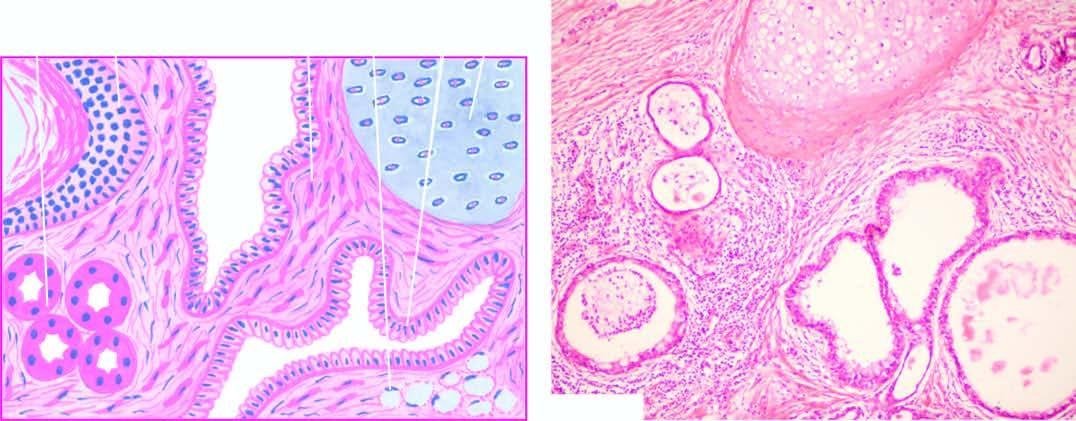what are also seen?
Answer the question using a single word or phrase. Islands of mature cartilage 